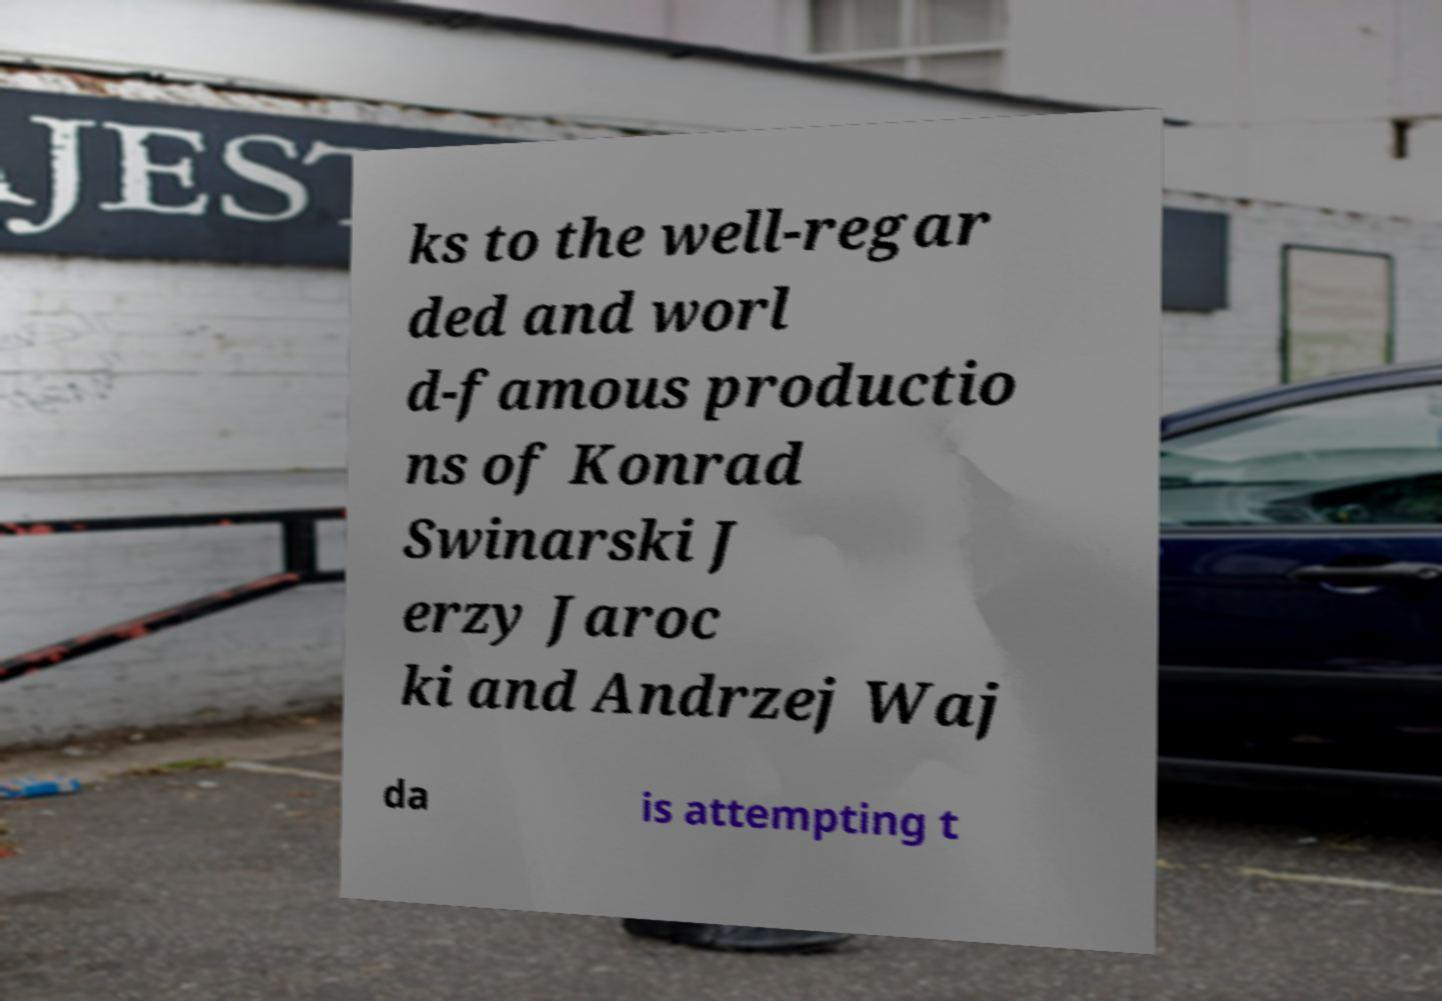Can you accurately transcribe the text from the provided image for me? ks to the well-regar ded and worl d-famous productio ns of Konrad Swinarski J erzy Jaroc ki and Andrzej Waj da is attempting t 